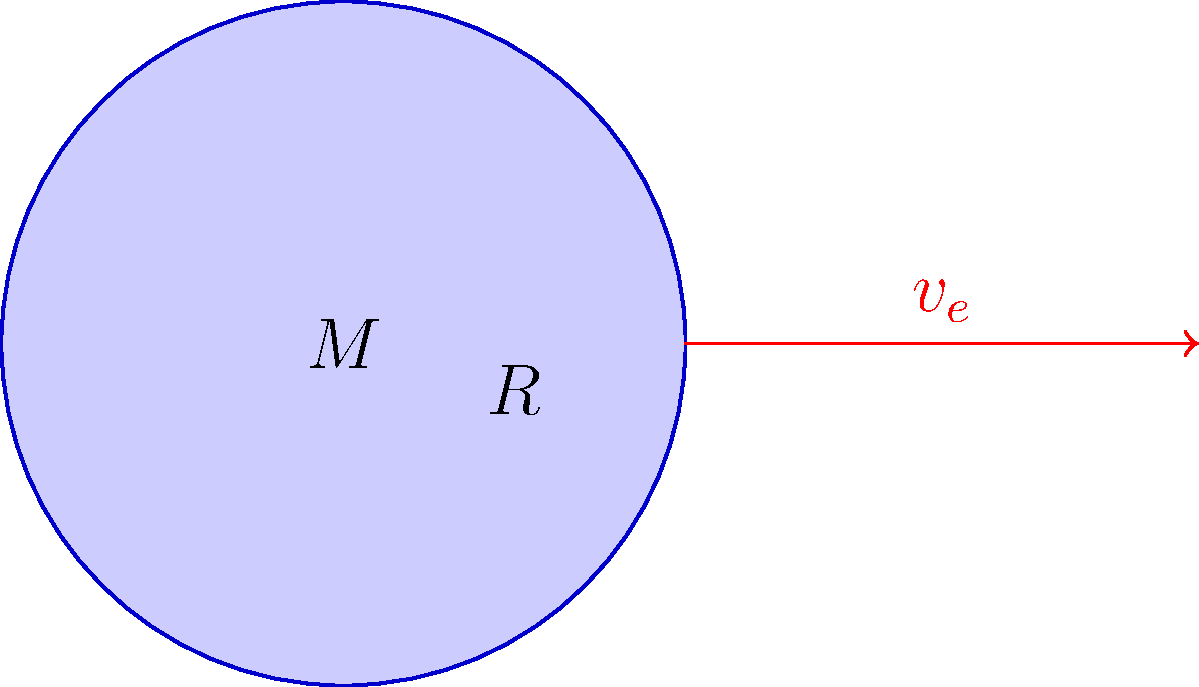In a math competition focused on astrophysics, participants are given a problem to calculate the escape velocity from a planet. The planet has a mass of $5.97 \times 10^{24}$ kg and a radius of $6.37 \times 10^6$ m. What is the escape velocity from this planet in km/s? (Use $G = 6.67 \times 10^{-11}$ N⋅m²/kg²) To solve this problem, we'll use the escape velocity formula and follow these steps:

1) The escape velocity formula is:
   $$v_e = \sqrt{\frac{2GM}{R}}$$
   where $G$ is the gravitational constant, $M$ is the mass of the planet, and $R$ is the radius of the planet.

2) We're given:
   $G = 6.67 \times 10^{-11}$ N⋅m²/kg²
   $M = 5.97 \times 10^{24}$ kg
   $R = 6.37 \times 10^6$ m

3) Let's substitute these values into the formula:
   $$v_e = \sqrt{\frac{2 \times (6.67 \times 10^{-11}) \times (5.97 \times 10^{24})}{6.37 \times 10^6}}$$

4) Simplify inside the square root:
   $$v_e = \sqrt{\frac{7.97 \times 10^{14}}{6.37 \times 10^6}}$$

5) Divide inside the square root:
   $$v_e = \sqrt{1.25 \times 10^8}$$

6) Take the square root:
   $$v_e = 1.118 \times 10^4 \text{ m/s}$$

7) Convert to km/s:
   $$v_e = 11.18 \text{ km/s}$$

8) Round to two decimal places:
   $$v_e = 11.18 \text{ km/s}$$
Answer: 11.18 km/s 